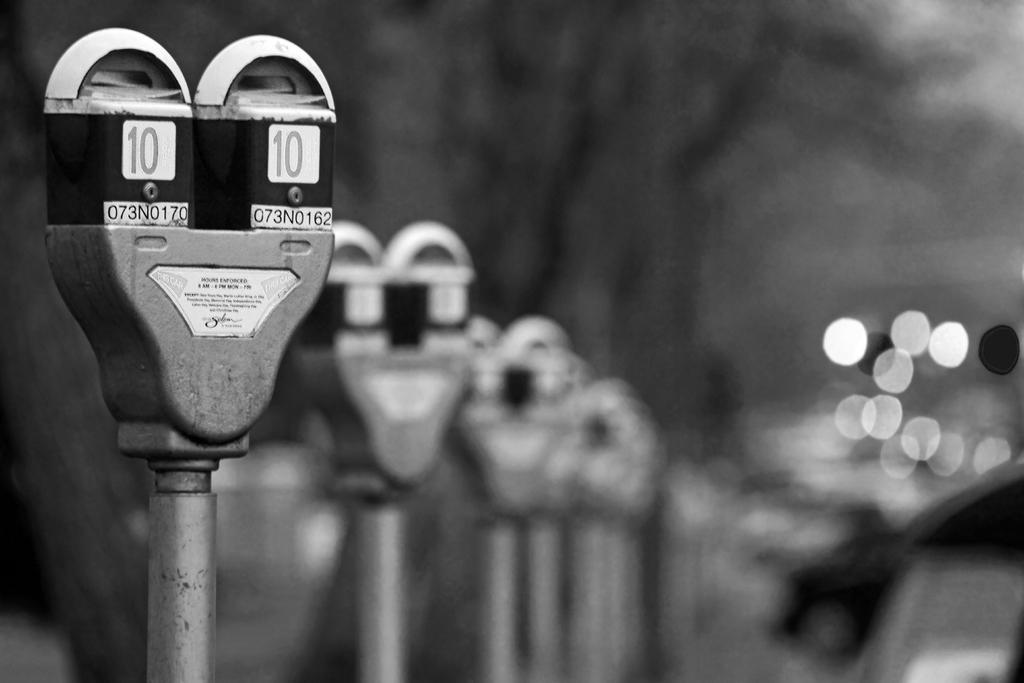What code is below the 10 on the left-most meter?
Keep it short and to the point. 073n0170. What number is on the meters?
Offer a very short reply. 10. 